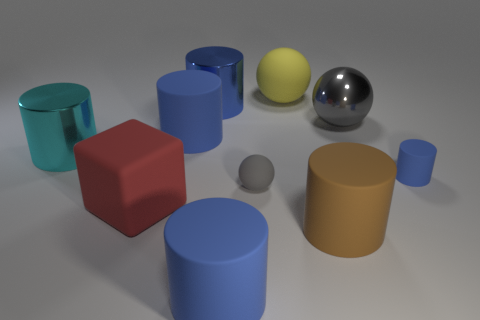Is the large red matte object the same shape as the blue metallic object?
Your answer should be compact. No. Is there anything else that is the same shape as the big red rubber thing?
Provide a short and direct response. No. There is a big object that is to the left of the red rubber block; is it the same color as the small rubber cylinder behind the brown object?
Offer a very short reply. No. Is the number of large brown rubber cylinders that are behind the big red rubber thing less than the number of big cubes that are on the right side of the tiny gray matte thing?
Make the answer very short. No. What is the shape of the small rubber thing that is on the left side of the small blue thing?
Ensure brevity in your answer.  Sphere. There is a small thing that is the same color as the shiny sphere; what is it made of?
Ensure brevity in your answer.  Rubber. How many other things are there of the same material as the tiny ball?
Offer a very short reply. 6. Is the shape of the cyan metallic thing the same as the blue rubber object that is in front of the tiny ball?
Your answer should be very brief. Yes. There is a brown thing that is made of the same material as the tiny sphere; what is its shape?
Provide a succinct answer. Cylinder. Is the number of blue shiny things that are in front of the tiny gray rubber object greater than the number of metallic cylinders right of the cyan cylinder?
Your answer should be very brief. No. 